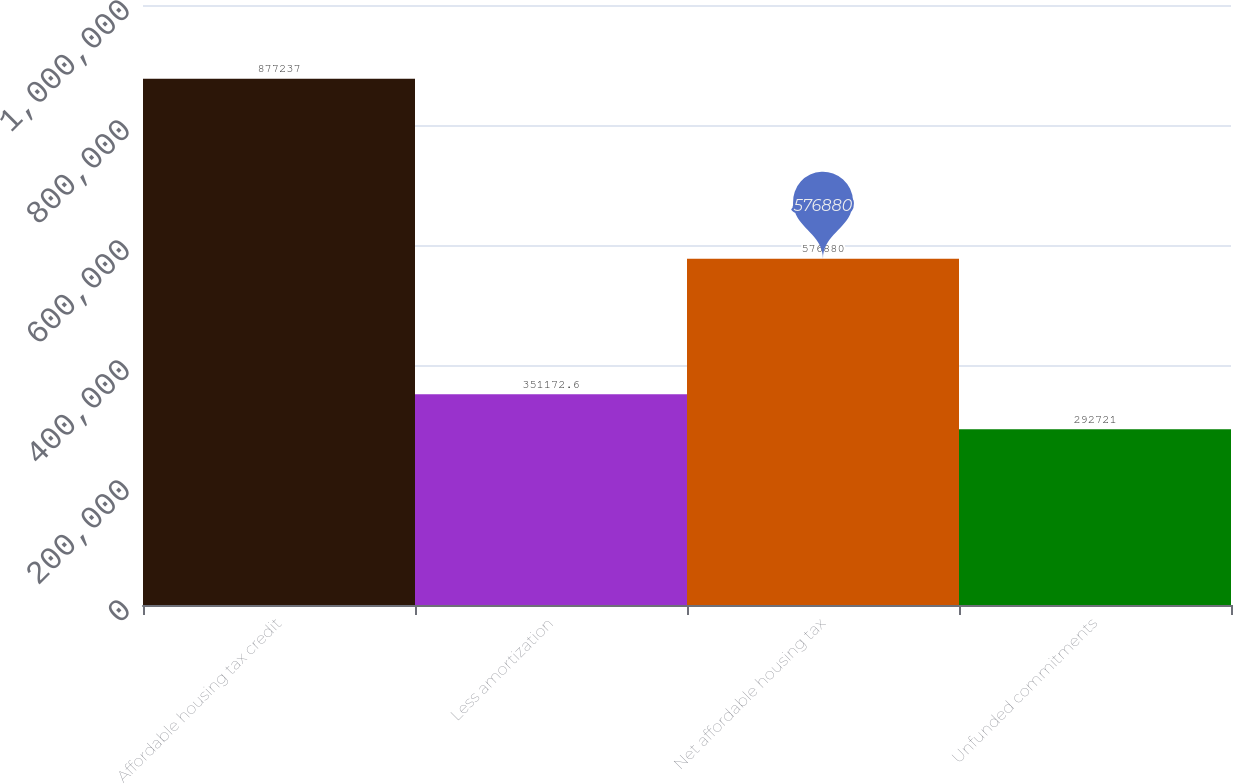Convert chart to OTSL. <chart><loc_0><loc_0><loc_500><loc_500><bar_chart><fcel>Affordable housing tax credit<fcel>Less amortization<fcel>Net affordable housing tax<fcel>Unfunded commitments<nl><fcel>877237<fcel>351173<fcel>576880<fcel>292721<nl></chart> 